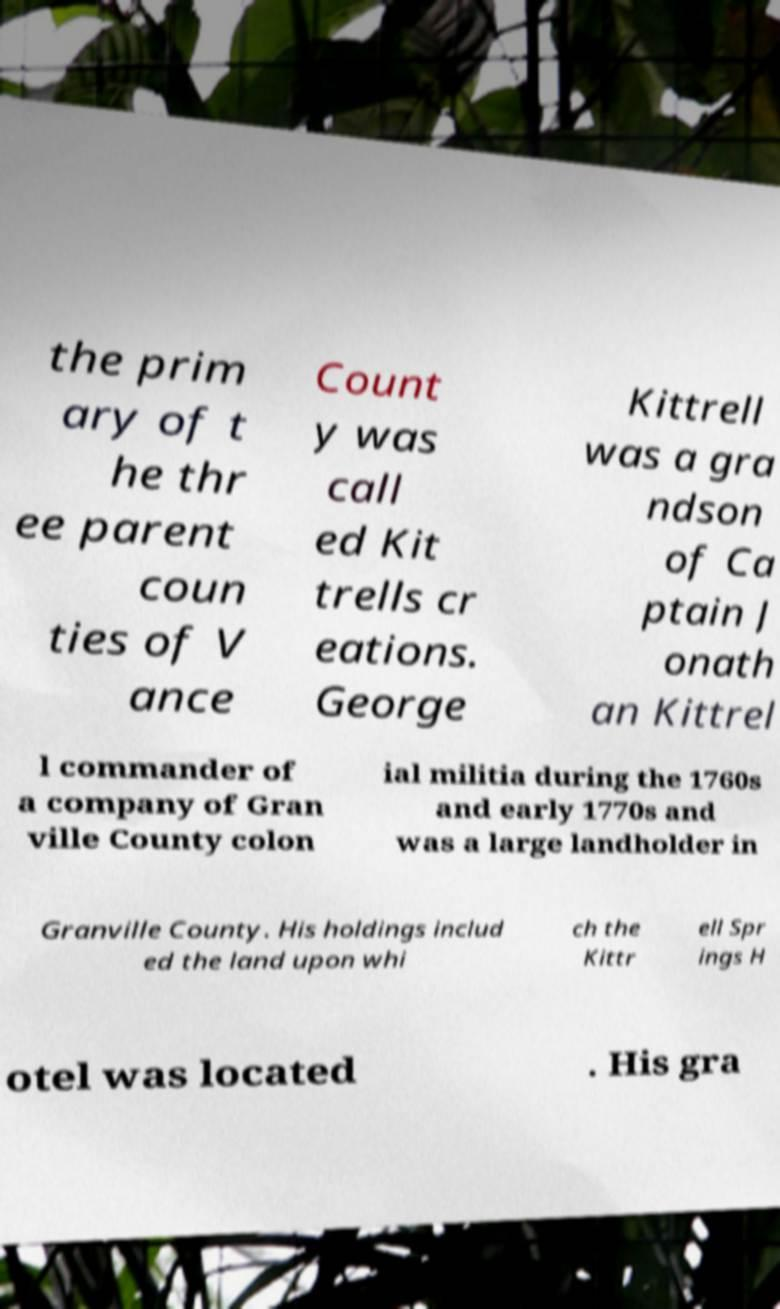Please identify and transcribe the text found in this image. the prim ary of t he thr ee parent coun ties of V ance Count y was call ed Kit trells cr eations. George Kittrell was a gra ndson of Ca ptain J onath an Kittrel l commander of a company of Gran ville County colon ial militia during the 1760s and early 1770s and was a large landholder in Granville County. His holdings includ ed the land upon whi ch the Kittr ell Spr ings H otel was located . His gra 